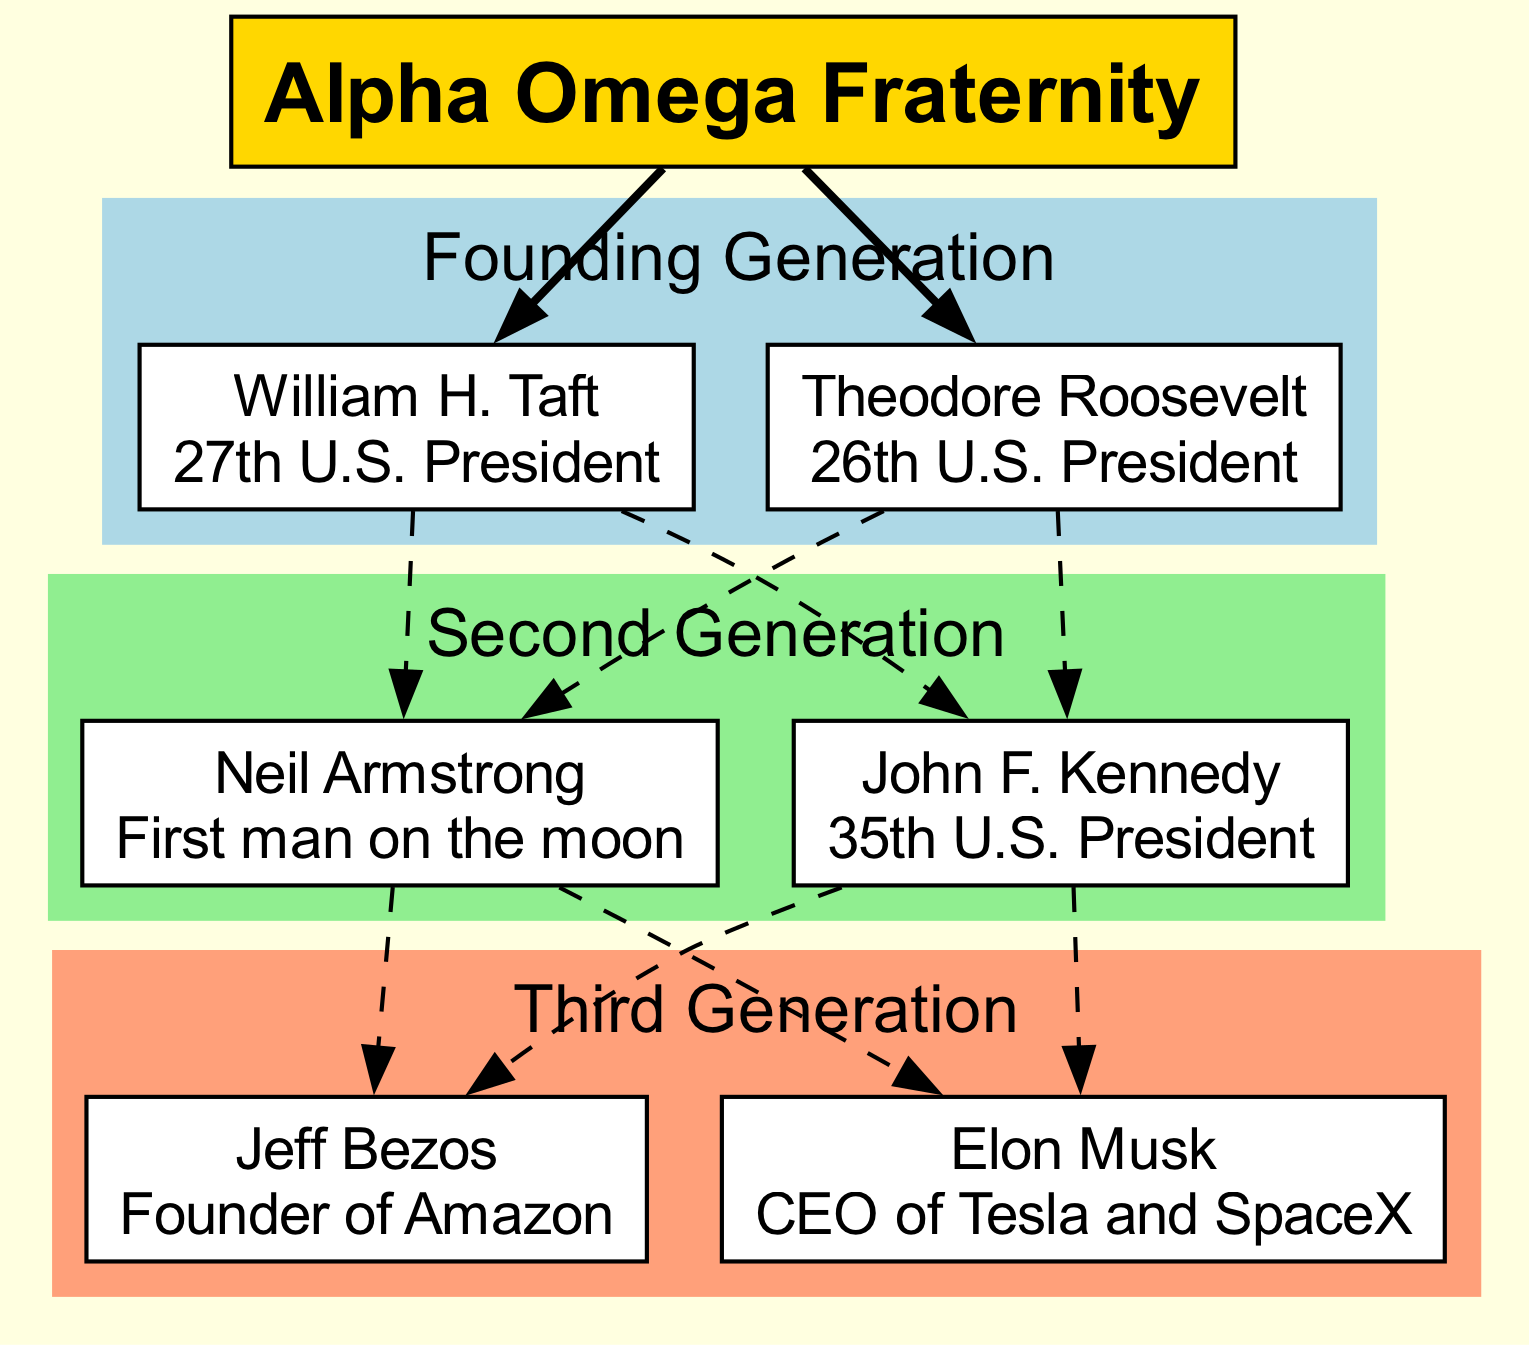What is the first-generation achievement of William H. Taft? To answer this, we look at the first generation of the family tree which includes William H. Taft, whose achievement is specified in the diagram. His achievement is listed directly under his name.
Answer: 27th U.S. President How many members are in the second generation? The second generation is outlined in the diagram, and we count the number of members listed there. According to the diagram, there are two members in the second generation: Neil Armstrong and John F. Kennedy.
Answer: 2 Who is listed as the CEO of Tesla and SpaceX? We examine the third generation of the family tree, where members' achievements are mentioned. The member who holds the title of CEO of Tesla and SpaceX is explicitly noted below his name in the diagram.
Answer: Elon Musk Which member of the Founding Generation is a former President? The first generation consists of two members, and we determine which one is described as a former President by looking at their achievements. Both William H. Taft and Theodore Roosevelt are former Presidents.
Answer: William H. Taft, Theodore Roosevelt What is the relationship between Neil Armstrong and John F. Kennedy? To answer this, we analyze the connections outlined in the second generation of the family tree. The connections will show the lineage from the founding generation to the second generation. Both Neil Armstrong and John F. Kennedy are siblings in the lineage.
Answer: Siblings Which generation does Jeff Bezos belong to? Jeff Bezos is a member of the family tree identified in the third generation. We simply find his name in the diagram and recognize which generation it belongs to.
Answer: Third Generation How many total members are in the family tree? We calculate the total number of members by adding the members from each generation listed in the diagram. There are 2 from the first, 2 from the second, and 2 from the third generation, which sums up to a total of 6 members.
Answer: 6 Who founded Amazon? We look at the third generation and find the member who is recognized for founding Amazon. His name and achievement are presented in the diagram.
Answer: Jeff Bezos What color represents the Founding Generation in the diagram? By reviewing the color scheme used for each generation in the diagram, we determine that the Founding Generation is associated with a specific color. The color used for the Founding Generation is light blue.
Answer: Light blue 